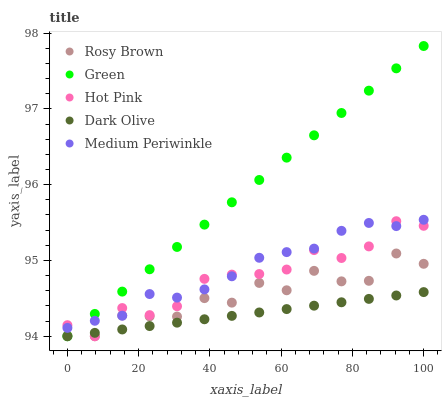Does Dark Olive have the minimum area under the curve?
Answer yes or no. Yes. Does Green have the maximum area under the curve?
Answer yes or no. Yes. Does Medium Periwinkle have the minimum area under the curve?
Answer yes or no. No. Does Medium Periwinkle have the maximum area under the curve?
Answer yes or no. No. Is Dark Olive the smoothest?
Answer yes or no. Yes. Is Rosy Brown the roughest?
Answer yes or no. Yes. Is Medium Periwinkle the smoothest?
Answer yes or no. No. Is Medium Periwinkle the roughest?
Answer yes or no. No. Does Dark Olive have the lowest value?
Answer yes or no. Yes. Does Medium Periwinkle have the lowest value?
Answer yes or no. No. Does Green have the highest value?
Answer yes or no. Yes. Does Medium Periwinkle have the highest value?
Answer yes or no. No. Is Dark Olive less than Medium Periwinkle?
Answer yes or no. Yes. Is Medium Periwinkle greater than Dark Olive?
Answer yes or no. Yes. Does Medium Periwinkle intersect Green?
Answer yes or no. Yes. Is Medium Periwinkle less than Green?
Answer yes or no. No. Is Medium Periwinkle greater than Green?
Answer yes or no. No. Does Dark Olive intersect Medium Periwinkle?
Answer yes or no. No. 